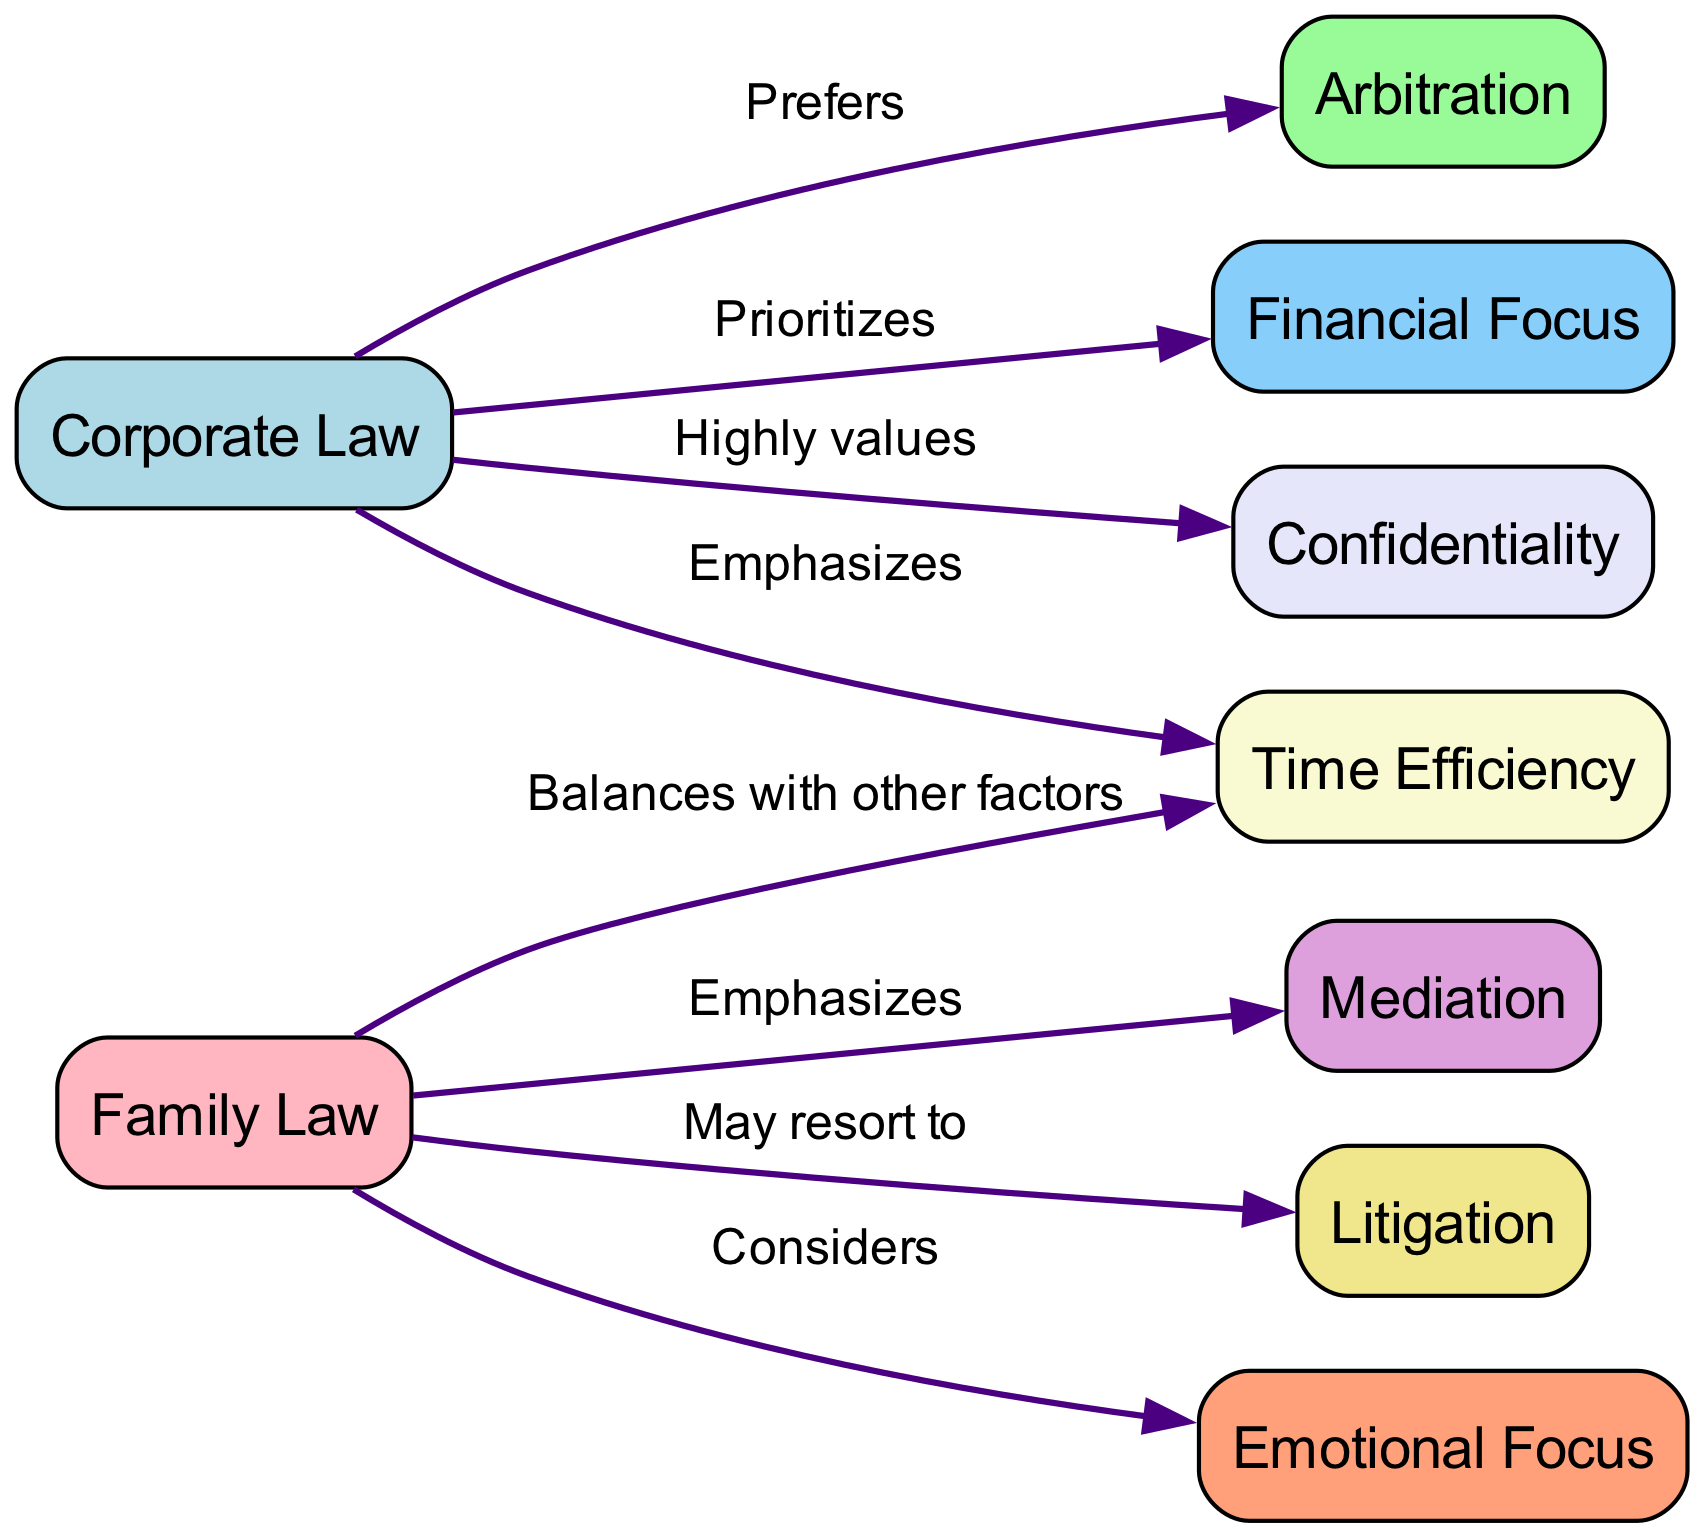What is the primary focus of corporate law when resolving disputes? The diagram indicates that corporate law prioritizes a financial focus, which means it views financial considerations as the main aspect while resolving disputes.
Answer: Financial Focus How many nodes represent dispute resolution methods in the diagram? The diagram lists three distinct dispute resolution methods: arbitration, mediation, and litigation. Therefore, by counting the unique methods, we find there are three nodes associated with dispute resolution.
Answer: 3 What does family law emphasize as its preferred approach to dispute resolution? The diagram shows that family law emphasizes mediation, highlighting that this is the preferred method used in family law when resolving conflicts.
Answer: Mediation Which dispute resolution method may family law resort to less frequently? The diagram indicates that family law may resort to litigation when other methods do not succeed, suggesting that litigation is an option but not the primary focus.
Answer: Litigation How does corporate law view the concept of time efficiency? According to the diagram, corporate law emphasizes time efficiency, meaning that it seeks to resolve disputes in a timely manner as a critical aspect of its approach.
Answer: Emphasizes What type of focus does family law consider in dispute resolution? The diagram illustrates that family law considers an emotional focus, which signifies that emotional factors and the well-being of individuals are taken into account in their dispute resolution process.
Answer: Emotional Focus How is the relationship between corporate law and confidentiality characterized? The diagram states that corporate law highly values confidentiality, suggesting that maintaining confidentiality is of paramount importance in the corporate law context.
Answer: Highly values What is the relationship between family law and time efficiency according to the diagram? The diagram shows that family law balances time efficiency with other factors, indicating that while it recognizes the importance of resolving disputes quickly, it also considers additional elements that might affect the resolution process.
Answer: Balances with other factors 